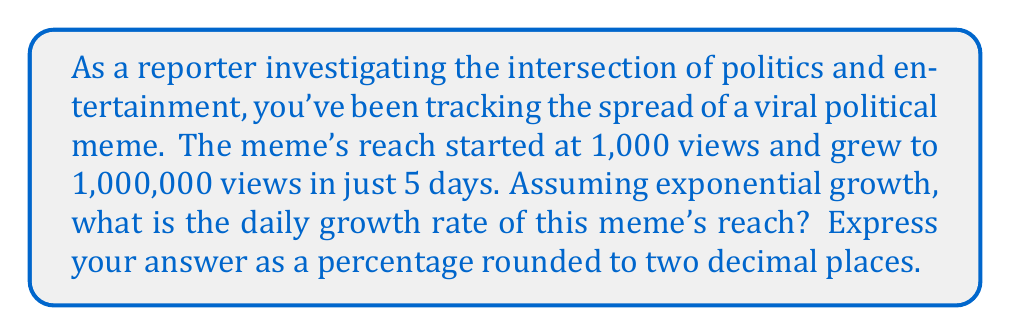Give your solution to this math problem. To solve this problem, we'll use the exponential growth formula:

$$A = P(1 + r)^t$$

Where:
$A$ = Final amount (1,000,000 views)
$P$ = Initial amount (1,000 views)
$r$ = Daily growth rate (what we're solving for)
$t$ = Time period (5 days)

Let's plug in the known values:

$$1,000,000 = 1,000(1 + r)^5$$

Now, let's solve for $r$:

1. Divide both sides by 1,000:
   $$1,000 = (1 + r)^5$$

2. Take the 5th root of both sides:
   $$\sqrt[5]{1,000} = 1 + r$$

3. Simplify:
   $$10^{\frac{3}{5}} = 1 + r$$

4. Subtract 1 from both sides:
   $$10^{\frac{3}{5}} - 1 = r$$

5. Calculate the value:
   $$r \approx 2.5118916...$$

6. Convert to a percentage by multiplying by 100:
   $$r \approx 251.18916\%$$

7. Round to two decimal places:
   $$r \approx 251.19\%$$
Answer: The daily growth rate of the meme's reach is approximately 251.19%. 